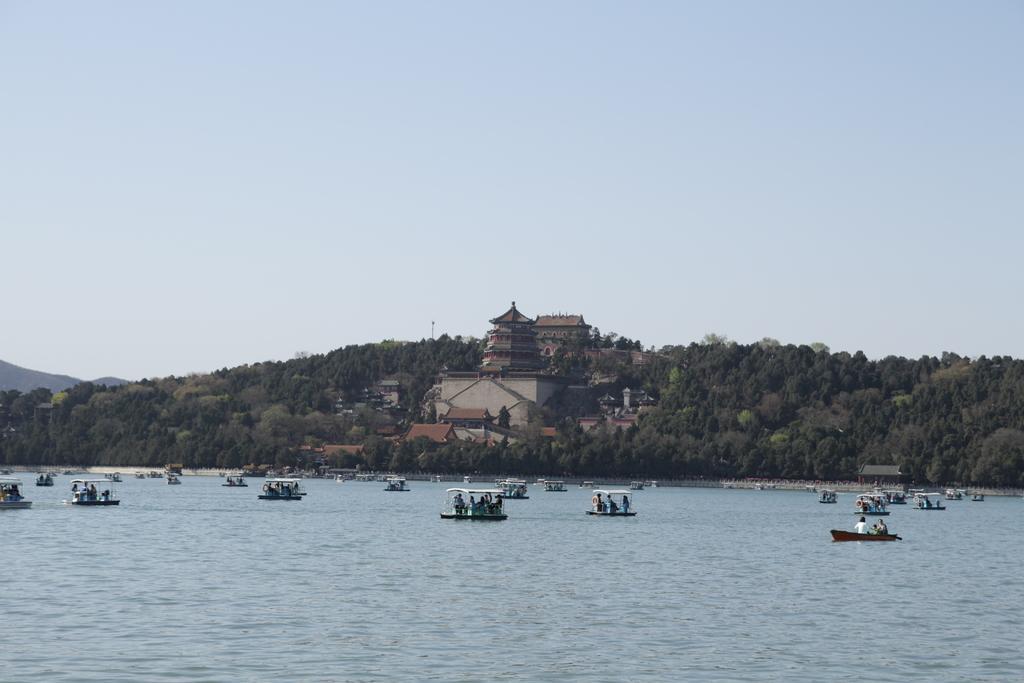Can you describe this image briefly? In this picture, there are many boats. The man in white T-shirt is sailing the boat in the water. This water might be a river. There are many trees and buildings in the background. At the top of the picture, we see the sky. 